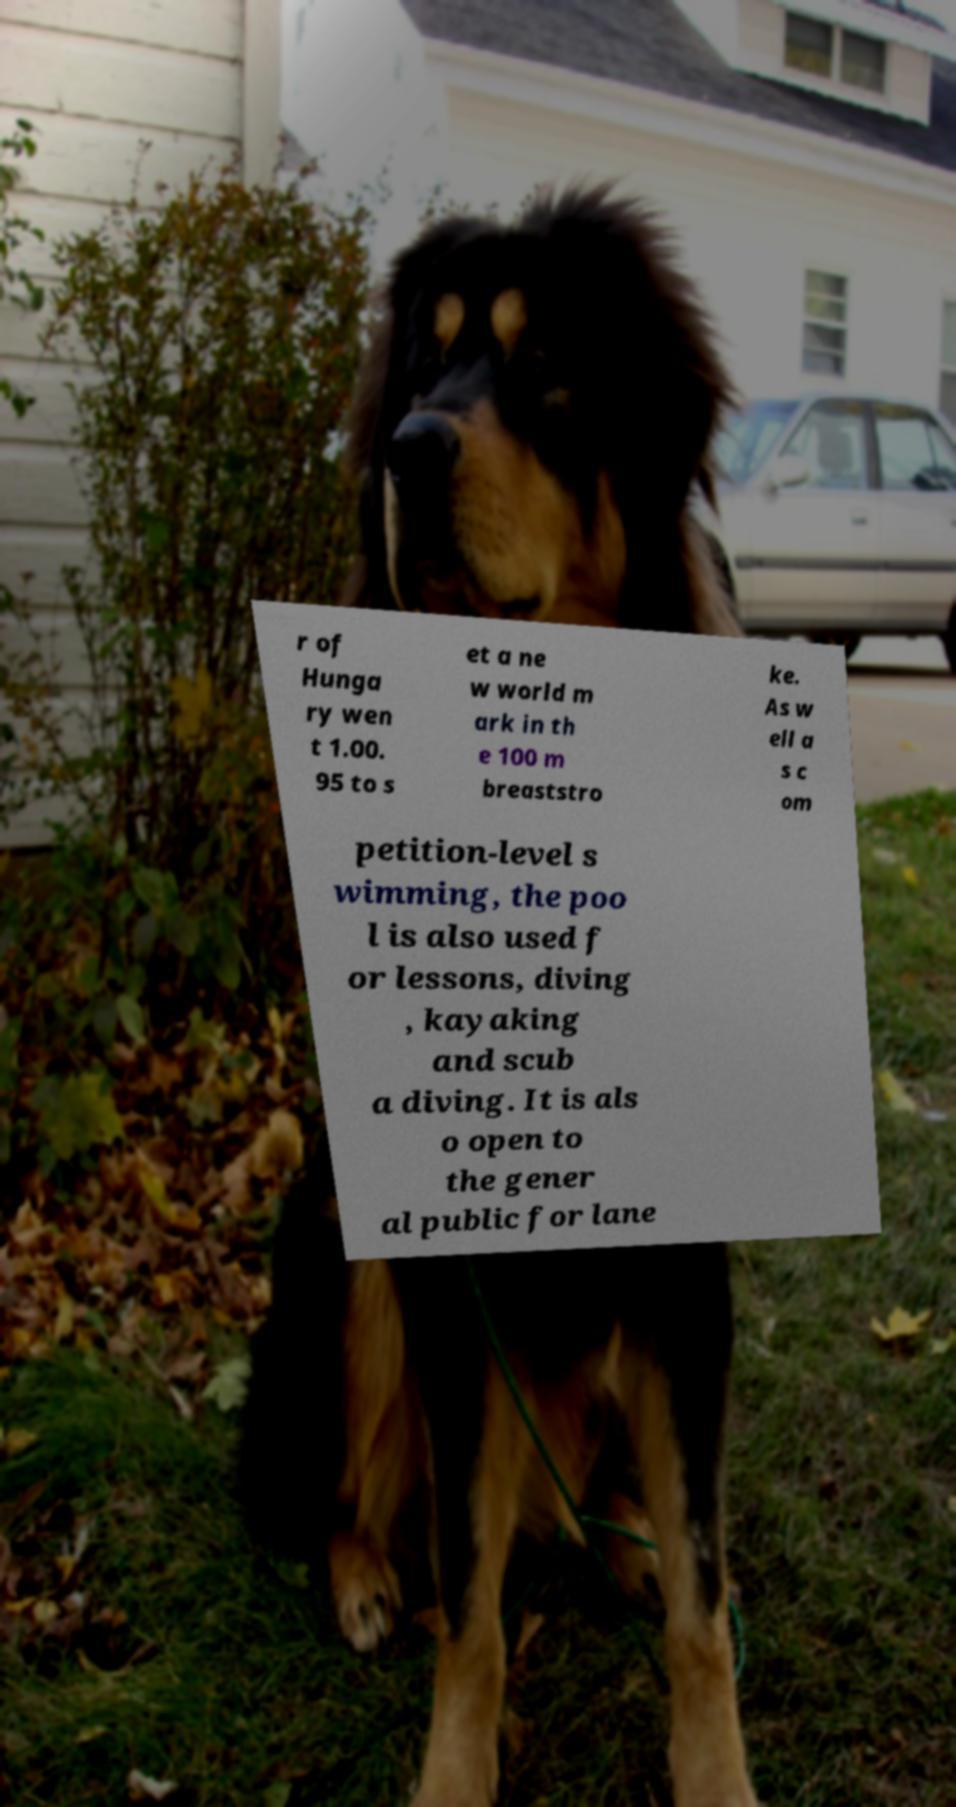I need the written content from this picture converted into text. Can you do that? r of Hunga ry wen t 1.00. 95 to s et a ne w world m ark in th e 100 m breaststro ke. As w ell a s c om petition-level s wimming, the poo l is also used f or lessons, diving , kayaking and scub a diving. It is als o open to the gener al public for lane 